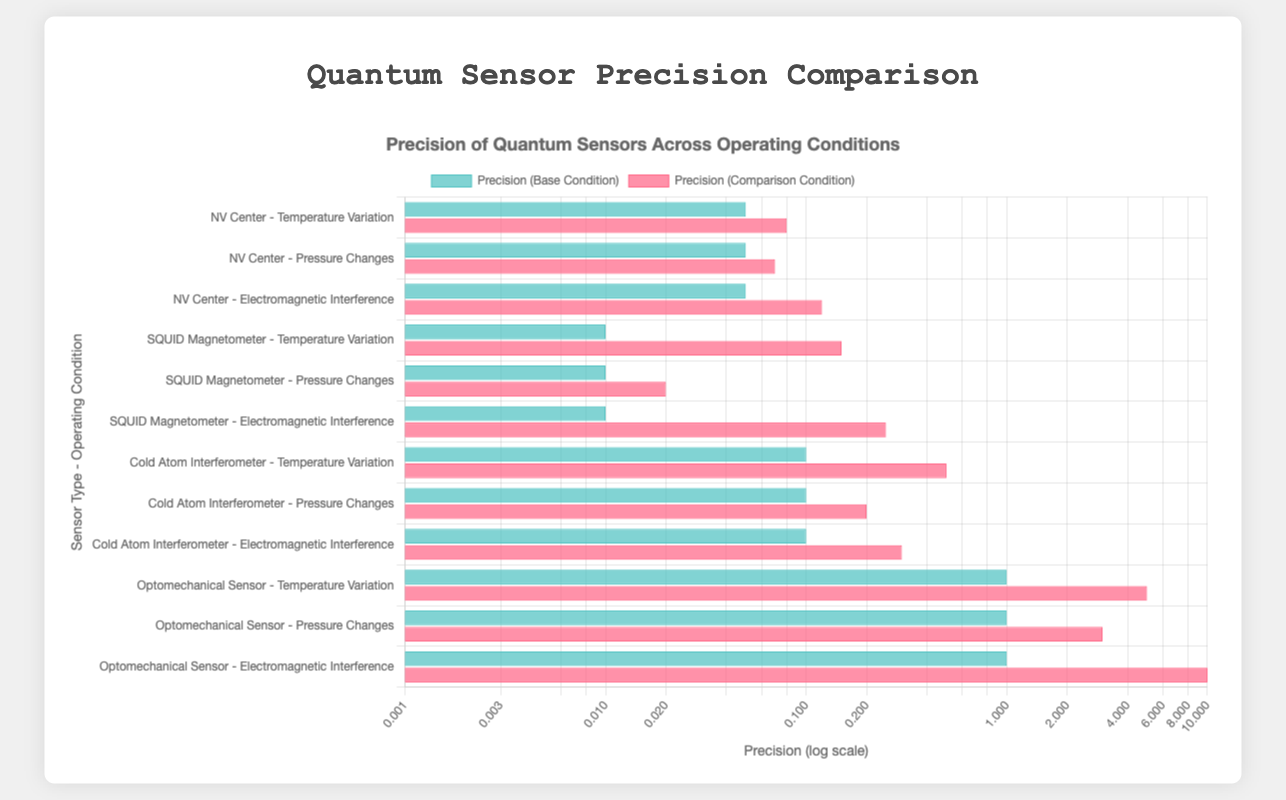Which quantum sensor has the highest increase in precision due to temperature variation? Look at the bars representing the temperature variation operating condition for all sensors. The largest increase in value (base vs. comparison) corresponds to the SQUID Magnetometer where precision goes from 0.01 fT at 4K to 0.15 fT at 77K.
Answer: SQUID Magnetometer Under low EMI conditions, which sensor has the worst precision? Compare the low EMI condition bars across all sensors. The Optomechanical Sensor has the highest value (1.0 aN) for low EMI, indicating the worst precision.
Answer: Optomechanical Sensor What is the difference in precision between ultra-high vacuum and high vacuum for the Cold Atom Interferometer? Subtract the precision values under ultra-high vacuum (0.10 pT) from those under high vacuum (0.20 pT) for the Cold Atom Interferometer: 0.20 - 0.10 = 0.10 pT.
Answer: 0.10 pT Which sensor shows the greatest impact of high electromagnetic interference on precision? Identify the sensors with the highest increase in the precision value from Low EMI to High EMI conditions. The Optomechanical Sensor shows the greatest spike from 1.0 aN to 10.0 aN.
Answer: Optomechanical Sensor How does the precision of NV Center compare at 1 atm and low EMI conditions? Compare the bars for NV Center at 1 atm (0.05 nT) and low EMI (0.05 nT). They are equal, indicating no difference in precision between these conditions.
Answer: Equal What is the average precision of the Cold Atom Interferometer across temperature variations? Add the precision values of Cold Atom Interferometer at 10K (0.10 pT) and 300K (0.50 pT) then divide by 2: (0.10 + 0.50) / 2 = 0.30 pT.
Answer: 0.30 pT Among the sensors, which one shows the least variance in precision due to pressure changes? Compare the differences in precision values for pressure changes in all sensors. The SQUID Magnetometer’s precision changes from 0.01 fT to 0.02 fT, which is the smallest change.
Answer: SQUID Magnetometer 